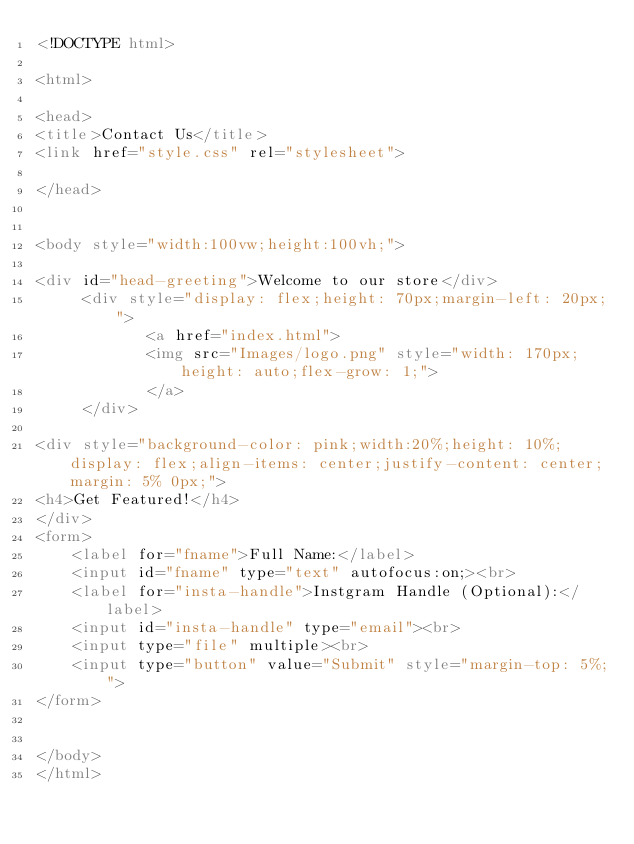<code> <loc_0><loc_0><loc_500><loc_500><_HTML_><!DOCTYPE html>

<html>
    
<head>
<title>Contact Us</title>
<link href="style.css" rel="stylesheet">
    
</head>


<body style="width:100vw;height:100vh;">

<div id="head-greeting">Welcome to our store</div>
     <div style="display: flex;height: 70px;margin-left: 20px;">
            <a href="index.html">
            <img src="Images/logo.png" style="width: 170px; height: auto;flex-grow: 1;">
            </a>
     </div>
    
<div style="background-color: pink;width:20%;height: 10%;display: flex;align-items: center;justify-content: center;margin: 5% 0px;">
<h4>Get Featured!</h4>
</div>
<form>
    <label for="fname">Full Name:</label>
    <input id="fname" type="text" autofocus:on;><br>
    <label for="insta-handle">Instgram Handle (Optional):</label>
    <input id="insta-handle" type="email"><br>
    <input type="file" multiple><br>
    <input type="button" value="Submit" style="margin-top: 5%;">
</form>
    
    
</body>
</html></code> 